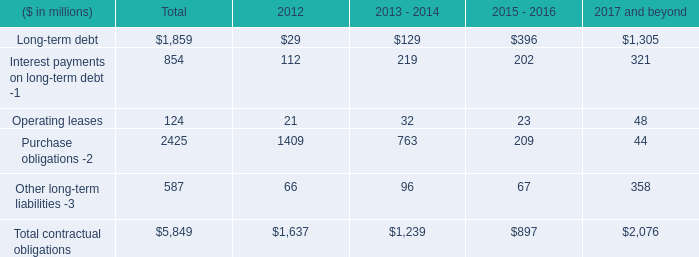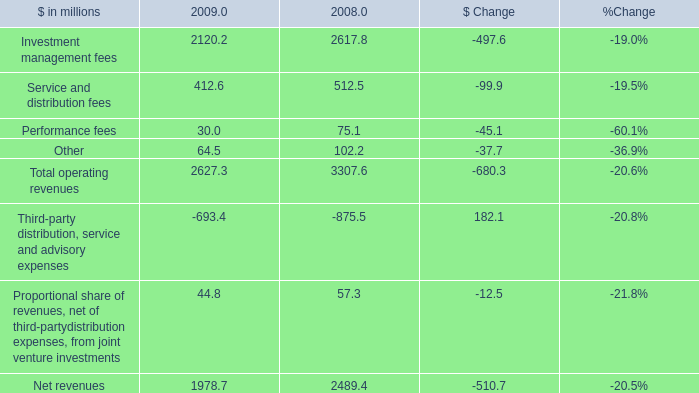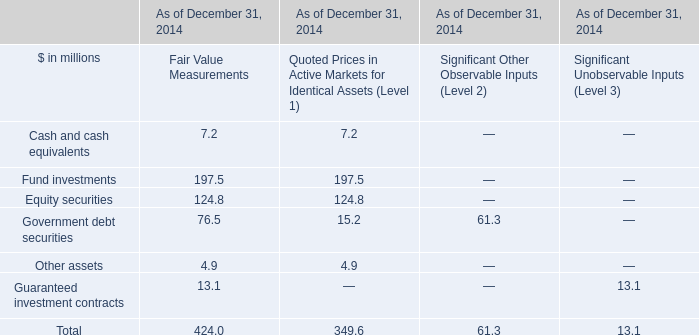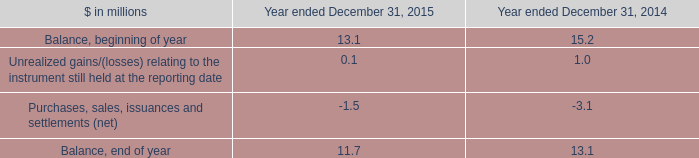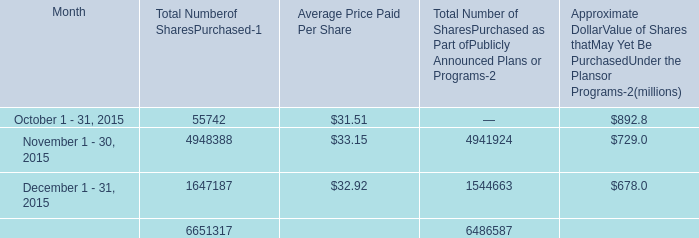When is Approximate DollarValue of Shares thatMay Yet Be PurchasedUnder the Plansor Programs the largest? 
Answer: October 1 - 31, 2015. 